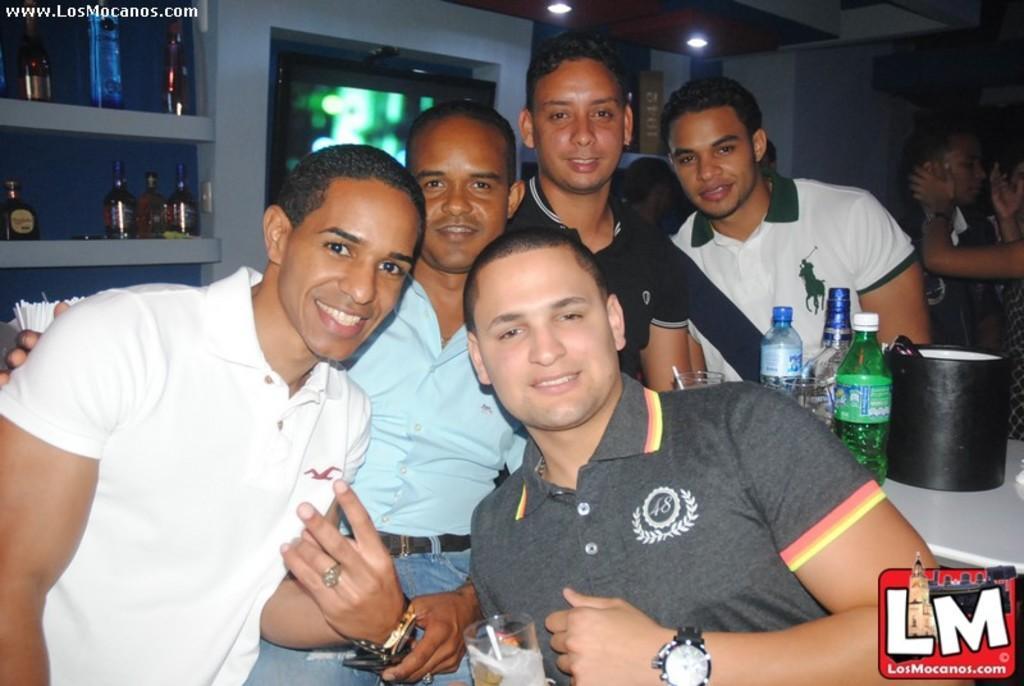Can you describe this image briefly? In this image it seems like there are group of people who are posing for a picture. At the background there are glass bottles which are kept on shelves. To the right corner their is a table on which there are bottles,cool drink bottles and glass. The man in front of the picture is holding a glass in his hand and wearing a watch to his left hand. 